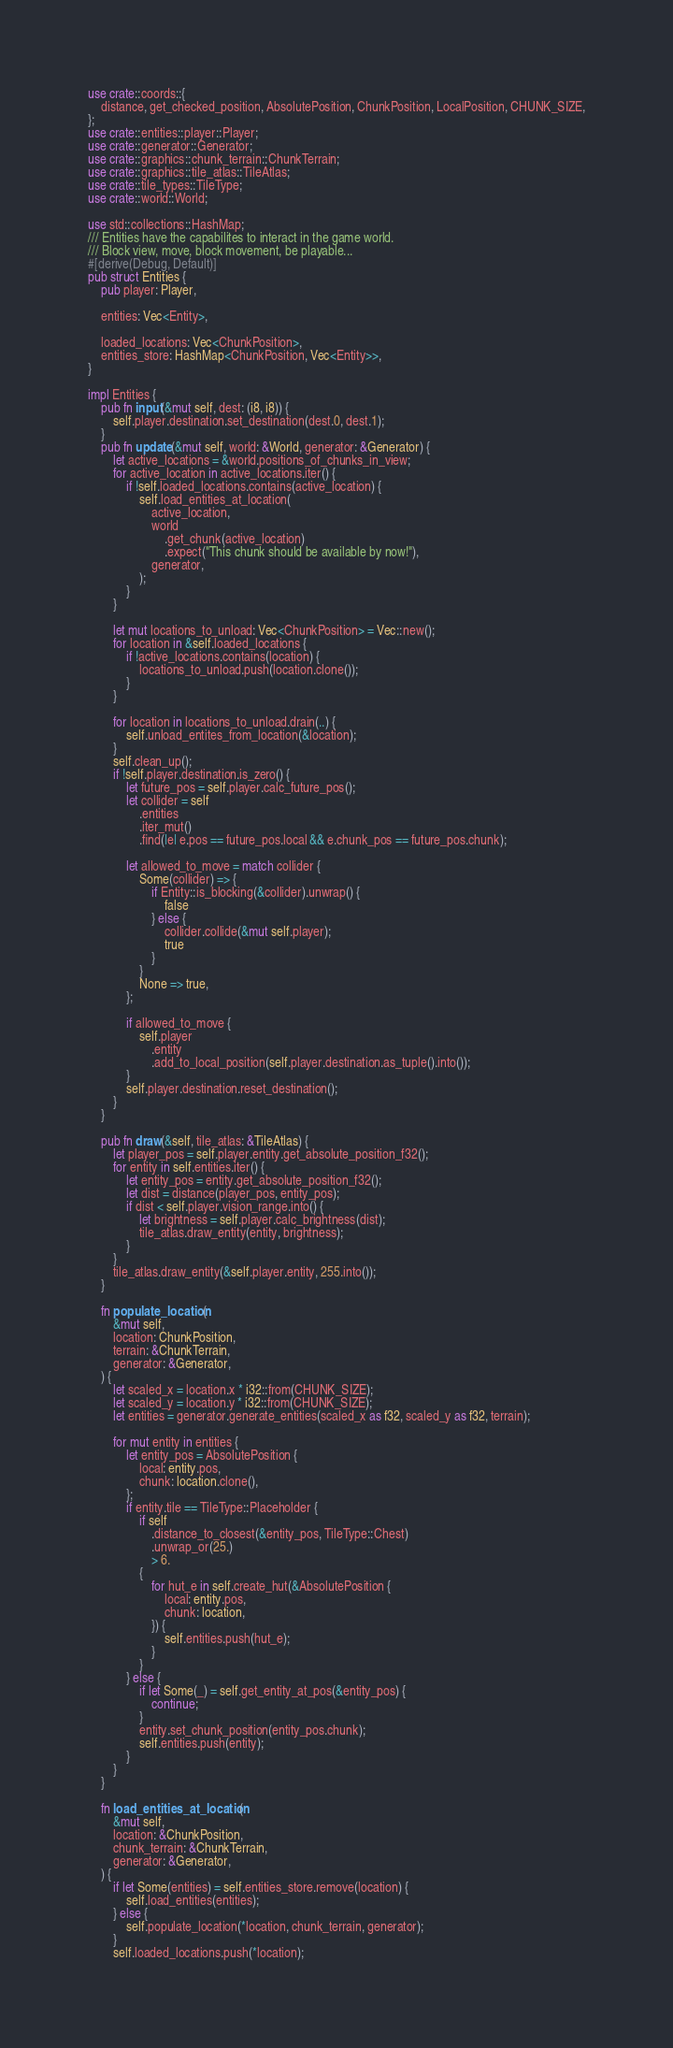<code> <loc_0><loc_0><loc_500><loc_500><_Rust_>use crate::coords::{
    distance, get_checked_position, AbsolutePosition, ChunkPosition, LocalPosition, CHUNK_SIZE,
};
use crate::entities::player::Player;
use crate::generator::Generator;
use crate::graphics::chunk_terrain::ChunkTerrain;
use crate::graphics::tile_atlas::TileAtlas;
use crate::tile_types::TileType;
use crate::world::World;

use std::collections::HashMap;
/// Entities have the capabilites to interact in the game world.
/// Block view, move, block movement, be playable...
#[derive(Debug, Default)]
pub struct Entities {
    pub player: Player,

    entities: Vec<Entity>,

    loaded_locations: Vec<ChunkPosition>,
    entities_store: HashMap<ChunkPosition, Vec<Entity>>,
}

impl Entities {
    pub fn input(&mut self, dest: (i8, i8)) {
        self.player.destination.set_destination(dest.0, dest.1);
    }
    pub fn update(&mut self, world: &World, generator: &Generator) {
        let active_locations = &world.positions_of_chunks_in_view;
        for active_location in active_locations.iter() {
            if !self.loaded_locations.contains(active_location) {
                self.load_entities_at_location(
                    active_location,
                    world
                        .get_chunk(active_location)
                        .expect("This chunk should be available by now!"),
                    generator,
                );
            }
        }

        let mut locations_to_unload: Vec<ChunkPosition> = Vec::new();
        for location in &self.loaded_locations {
            if !active_locations.contains(location) {
                locations_to_unload.push(location.clone());
            }
        }

        for location in locations_to_unload.drain(..) {
            self.unload_entites_from_location(&location);
        }
        self.clean_up();
        if !self.player.destination.is_zero() {
            let future_pos = self.player.calc_future_pos();
            let collider = self
                .entities
                .iter_mut()
                .find(|e| e.pos == future_pos.local && e.chunk_pos == future_pos.chunk);

            let allowed_to_move = match collider {
                Some(collider) => {
                    if Entity::is_blocking(&collider).unwrap() {
                        false
                    } else {
                        collider.collide(&mut self.player);
                        true
                    }
                }
                None => true,
            };

            if allowed_to_move {
                self.player
                    .entity
                    .add_to_local_position(self.player.destination.as_tuple().into());
            }
            self.player.destination.reset_destination();
        }
    }

    pub fn draw(&self, tile_atlas: &TileAtlas) {
        let player_pos = self.player.entity.get_absolute_position_f32();
        for entity in self.entities.iter() {
            let entity_pos = entity.get_absolute_position_f32();
            let dist = distance(player_pos, entity_pos);
            if dist < self.player.vision_range.into() {
                let brightness = self.player.calc_brightness(dist);
                tile_atlas.draw_entity(entity, brightness);
            }
        }
        tile_atlas.draw_entity(&self.player.entity, 255.into());
    }

    fn populate_location(
        &mut self,
        location: ChunkPosition,
        terrain: &ChunkTerrain,
        generator: &Generator,
    ) {
        let scaled_x = location.x * i32::from(CHUNK_SIZE);
        let scaled_y = location.y * i32::from(CHUNK_SIZE);
        let entities = generator.generate_entities(scaled_x as f32, scaled_y as f32, terrain);

        for mut entity in entities {
            let entity_pos = AbsolutePosition {
                local: entity.pos,
                chunk: location.clone(),
            };
            if entity.tile == TileType::Placeholder {
                if self
                    .distance_to_closest(&entity_pos, TileType::Chest)
                    .unwrap_or(25.)
                    > 6.
                {
                    for hut_e in self.create_hut(&AbsolutePosition {
                        local: entity.pos,
                        chunk: location,
                    }) {
                        self.entities.push(hut_e);
                    }
                }
            } else {
                if let Some(_) = self.get_entity_at_pos(&entity_pos) {
                    continue;
                }
                entity.set_chunk_position(entity_pos.chunk);
                self.entities.push(entity);
            }
        }
    }

    fn load_entities_at_location(
        &mut self,
        location: &ChunkPosition,
        chunk_terrain: &ChunkTerrain,
        generator: &Generator,
    ) {
        if let Some(entities) = self.entities_store.remove(location) {
            self.load_entities(entities);
        } else {
            self.populate_location(*location, chunk_terrain, generator);
        }
        self.loaded_locations.push(*location);</code> 